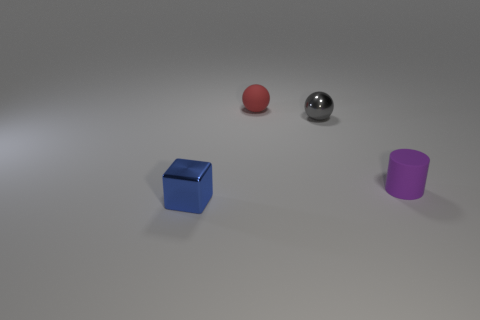Subtract all red balls. How many balls are left? 1 Subtract all blocks. How many objects are left? 3 Add 3 tiny blue metallic cylinders. How many objects exist? 7 Subtract all cyan blocks. Subtract all red cylinders. How many blocks are left? 1 Subtract all blue cylinders. How many red balls are left? 1 Subtract all matte balls. Subtract all small rubber things. How many objects are left? 1 Add 1 tiny metallic objects. How many tiny metallic objects are left? 3 Add 3 gray matte spheres. How many gray matte spheres exist? 3 Subtract 1 blue blocks. How many objects are left? 3 Subtract 1 balls. How many balls are left? 1 